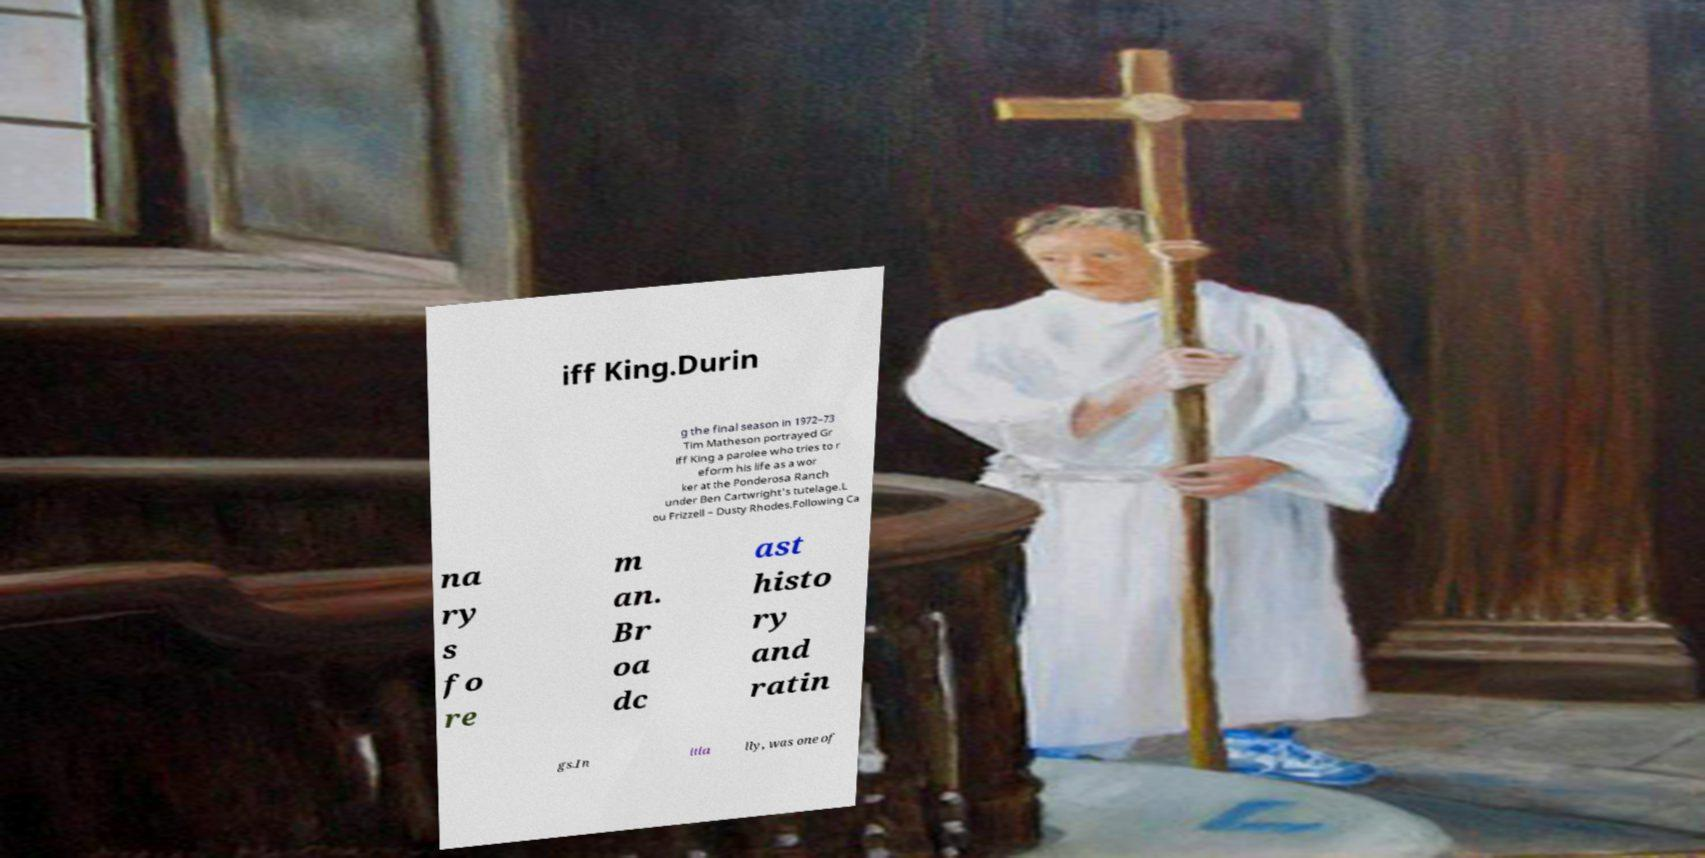Could you assist in decoding the text presented in this image and type it out clearly? iff King.Durin g the final season in 1972–73 Tim Matheson portrayed Gr iff King a parolee who tries to r eform his life as a wor ker at the Ponderosa Ranch under Ben Cartwright's tutelage.L ou Frizzell – Dusty Rhodes.Following Ca na ry s fo re m an. Br oa dc ast histo ry and ratin gs.In itia lly, was one of 